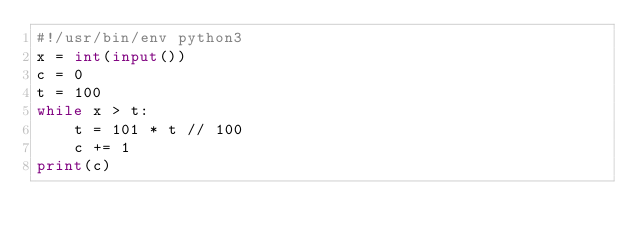<code> <loc_0><loc_0><loc_500><loc_500><_Python_>#!/usr/bin/env python3
x = int(input())
c = 0
t = 100
while x > t:
    t = 101 * t // 100
    c += 1
print(c)
</code> 